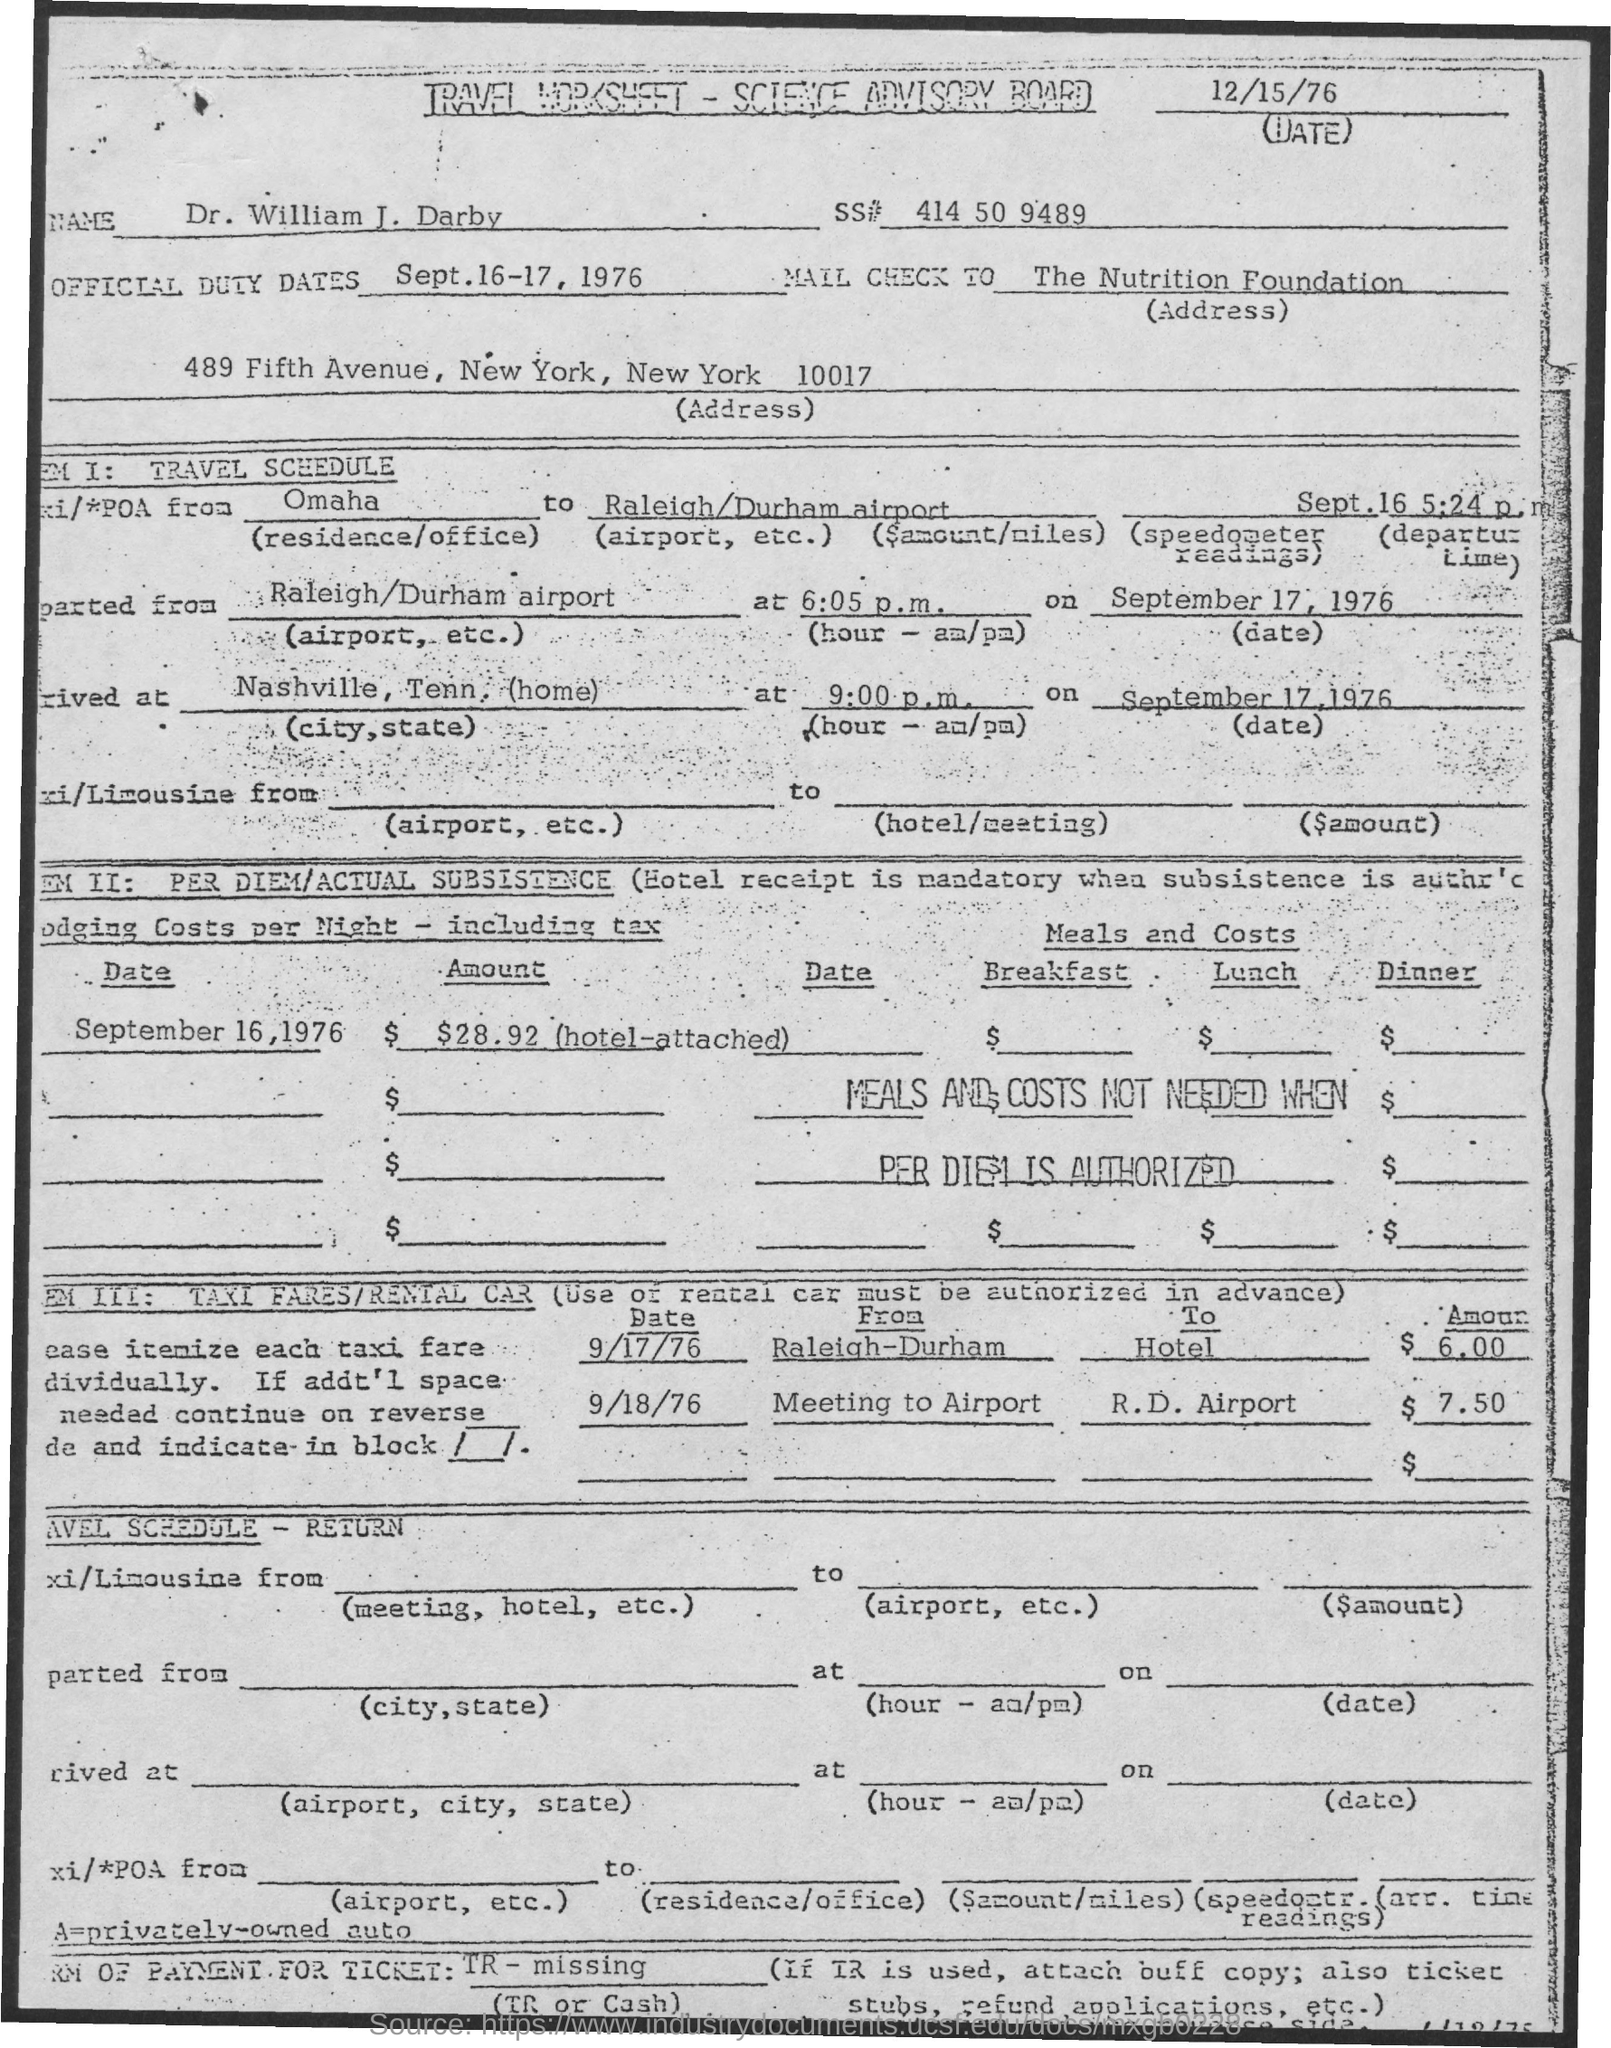What is the Date?
Give a very brief answer. 12/15/76. What is the Name?
Offer a terse response. Dr. William J. Darby. What is the SS#?
Provide a short and direct response. 414 50 9489. What is the Official Duty Dates?
Your answer should be compact. Sept.16-17, 1976. The check should be mailed to whom?
Provide a succinct answer. The Nutrition Foundation. What is the Taxi fare for date 9/17/76?
Provide a short and direct response. $6.00. What is the Taxi fare for date 9/18/76?
Offer a very short reply. $7.50. Where is the Taxi going "From" on 9/17/76?
Your answer should be compact. Raleigh-Durham. Where is the Taxi going "To" on 9/17/76?
Ensure brevity in your answer.  Hotel. Where is the Taxi going "To" on 9/18/76?
Your response must be concise. R.D. Airport. 